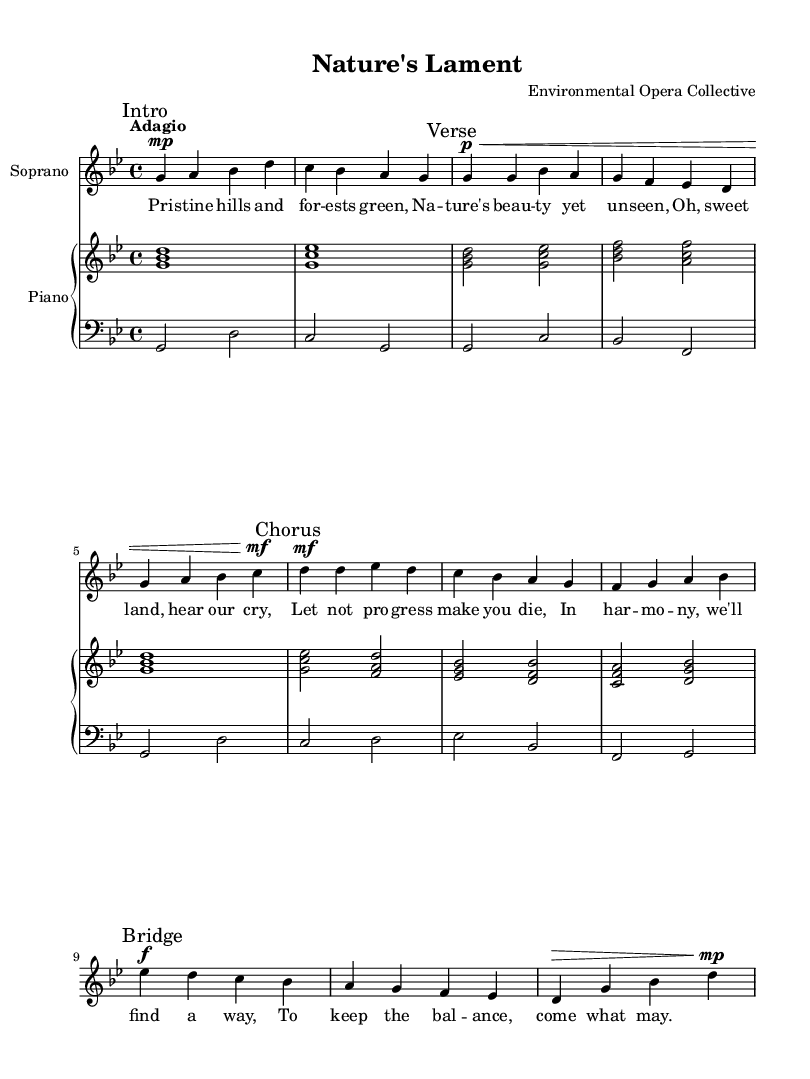What is the key signature of this music? The key signature is G minor, which has two flats. In the provided LilyPond code, this can be identified in the "global" section where "g \minor" is indicated.
Answer: G minor What is the time signature of this music? The time signature is 4/4, as mentioned in the "global" section of the code with the statement "\time 4/4". This indicates that there are four quarter-note beats in each measure.
Answer: 4/4 What tempo is marked for this piece? The tempo marked is "Adagio," which means a slow tempo. This is indicated in the "global" section where the tempo is specified.
Answer: Adagio What dynamic marking starts the soprano part? The dynamic marking at the beginning of the soprano part is "mp," which stands for mezzo-piano, indicating a moderately soft volume. This is found at the start of the first measure of the soprano part.
Answer: mp How many sections are there in the soprano part? There are four sections labeled as "Intro," "Verse," "Chorus," and "Bridge." Each section is marked in the soprano part with specific comments that outline these divisions in the lyrics.
Answer: Four What is the thematic concern expressed in the lyrics? The thematic concern expressed in the lyrics revolves around preserving nature and the balance between progress and environmental conservation, as evidenced by phrases like "Let not progress make you die." The lyrics highlight a plea for harmony with nature in the face of industrialization.
Answer: Preservation of nature 